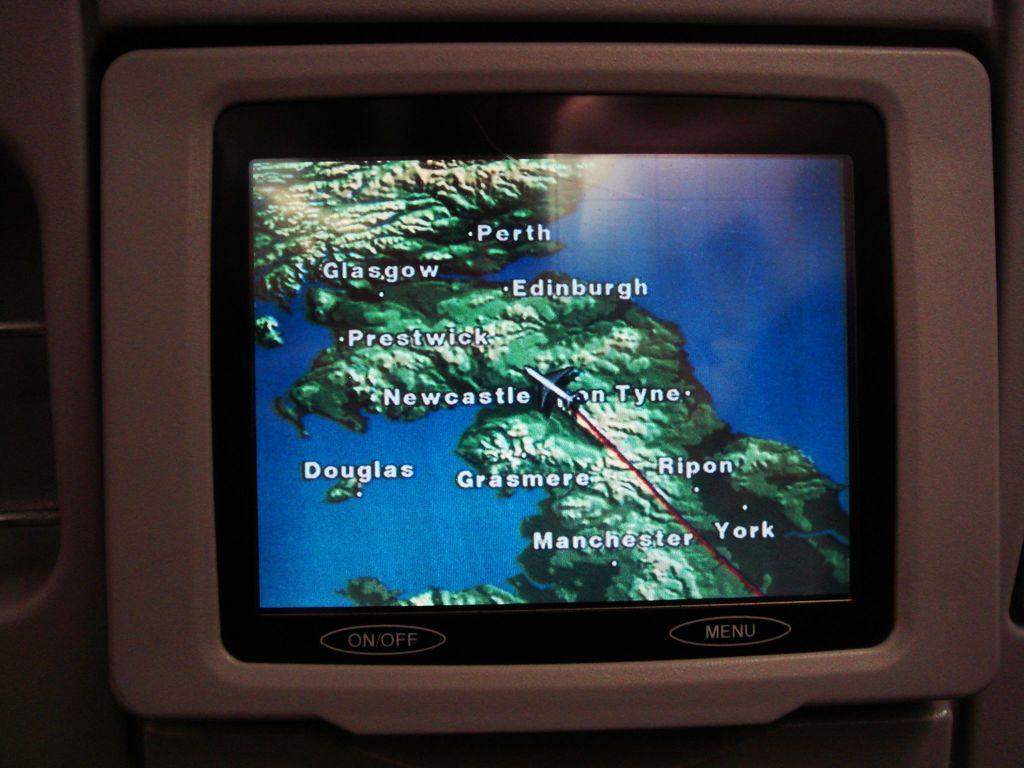Provide a one-sentence caption for the provided image. A screen on the back of a plane seat shows the progress of a flight over Scotland. 